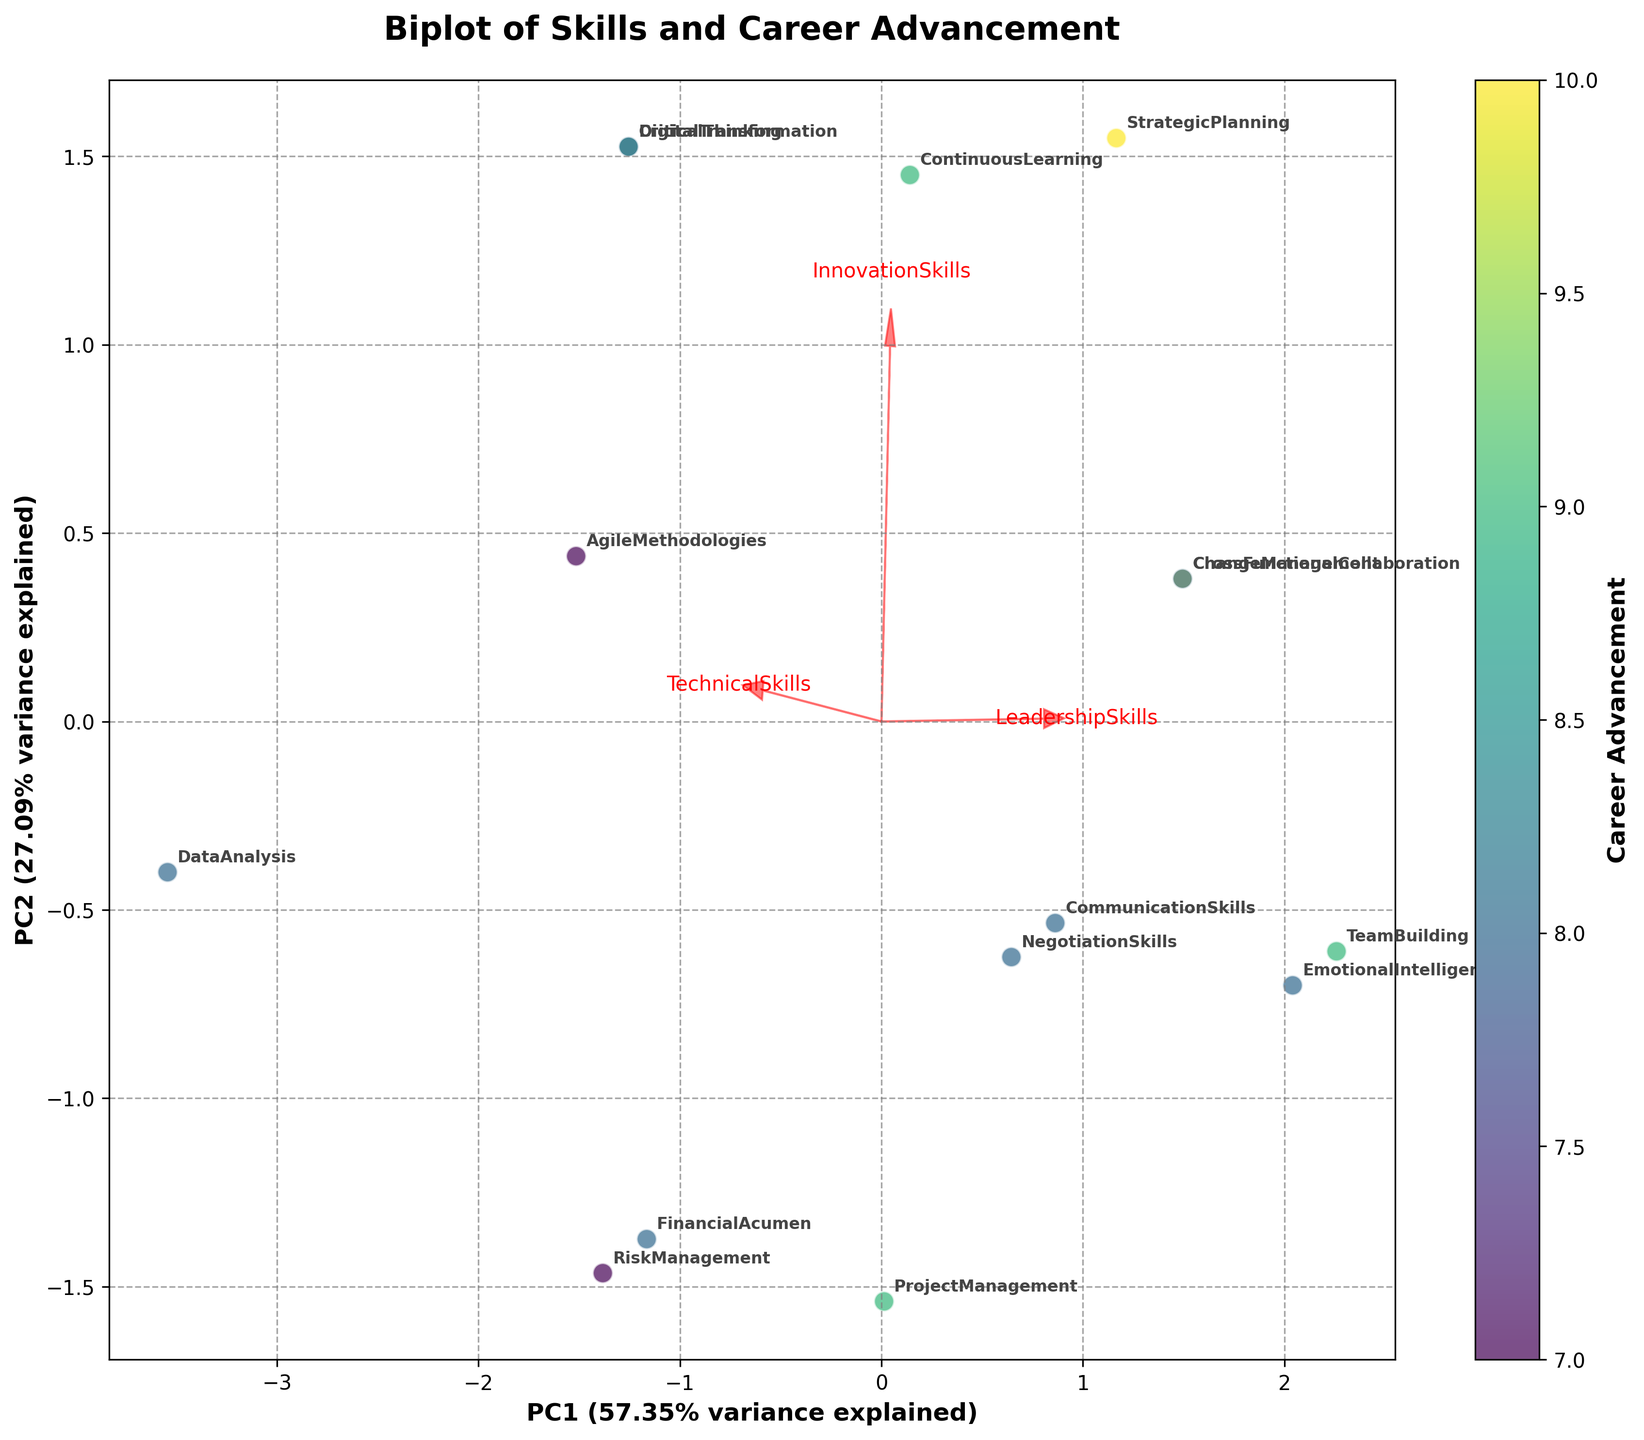What is the title of the biplot? The biplot has a title displayed at the top of the figure. It reads "Biplot of Skills and Career Advancement," indicating the context of the skills being analyzed for their relation to career advancement opportunities.
Answer: Biplot of Skills and Career Advancement How many data points are plotted in the biplot? To determine the number of data points, you can count the number of unique labels annotated in the biplot. Each data point corresponds to a specific variable such as Project Management, Data Analysis, etc. There are 15 labeled data points.
Answer: 15 Which skill vector is the longest, indicating the highest contribution to the principal components? In a biplot, the length of the vectors represents the contribution of each skill to the principal components. By comparing the lengths of the vectors, we see that "StrategicPlanning" has the longest vector, indicating it has the highest contribution.
Answer: StrategicPlanning Are there any skills that are positively correlated with Career Advancement? To determine positive correlation, look for skills whose vectors point in the same general direction as the color gradient indicating Career Advancement values. Skills like "ChangeManagement" and "StrategicPlanning" are positively correlated with Career Advancement since their vectors point towards higher Career Advancement values (yellowish part of the gradient).
Answer: ChangeManagement and StrategicPlanning Which two skills are closest to each other on the biplot, indicating they have similar contributions to the principal components? By examining the distances between data points on the biplot, we can identify the two closest skills. "TeamBuilding" and "EmotionalIntelligence" are positioned very close to each other, indicating similar contributions to the principal components.
Answer: TeamBuilding and EmotionalIntelligence What percentage of variance is explained by PC1 and PC2 together? The explained variance for each principal component is displayed on the axes labels. PC1 explains 35.6% of the variance and PC2 explains 32.2% of the variance. Summing these percentages gives the total explained variance.
Answer: 67.8% Which skill is placed farthest to the right on the biplot along PC1? To find the skill farthest to the right along PC1, look for the data point with the highest value on the X-axis (PC1). "FinancialAcumen" is positioned farthest to the right along PC1.
Answer: FinancialAcumen How does TechnicalSkills relate to InnovationSkills based on their vectors' angles? To assess the relationship, compare the vectors representing TechnicalSkills and InnovationSkills. Both vectors point in similar directions, indicating a positive correlation between these skills.
Answer: Positive correlation Which skills are least related to the principal components based on the lengths of their vectors? Skills with the shortest vectors have the least contribution to the principal components. "EmotionalIntelligence" and "RiskManagement" have noticeably shorter vectors, indicating they are less related to the principal components compared to other skills.
Answer: EmotionalIntelligence and RiskManagement 